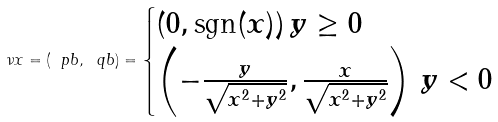Convert formula to latex. <formula><loc_0><loc_0><loc_500><loc_500>\nu x = ( \ p b , \ q b ) = \begin{cases} ( 0 , \text {sgn} ( x ) ) \, y \geq 0 \\ \left ( - \frac { y } { \sqrt { x ^ { 2 } + y ^ { 2 } } } , \frac { x } { \sqrt { x ^ { 2 } + y ^ { 2 } } } \right ) \, y < 0 \end{cases}</formula> 